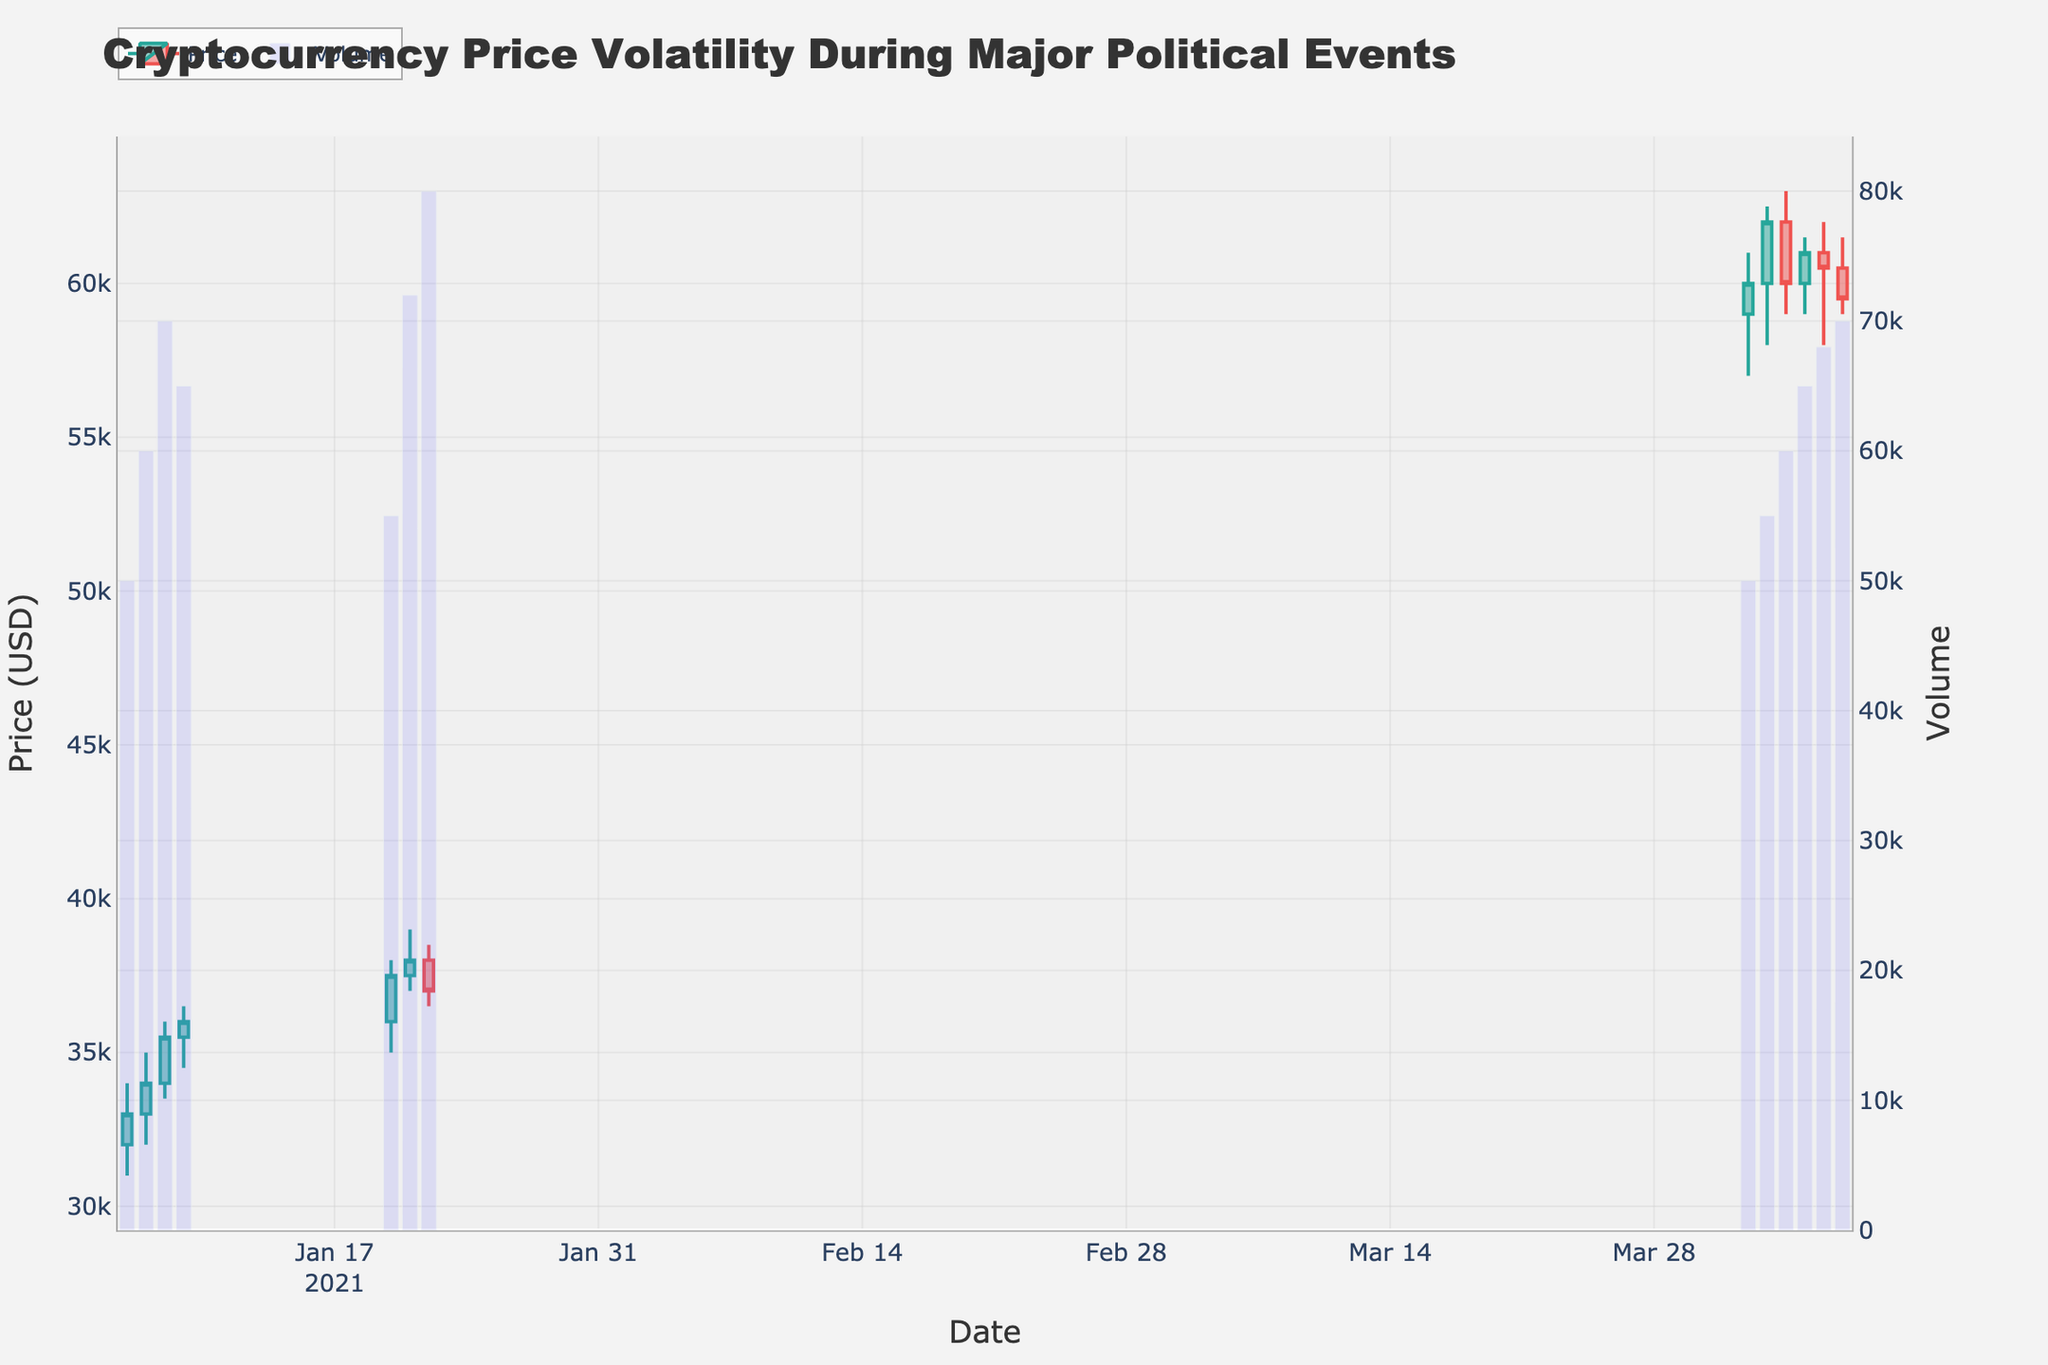What is the title of the plot? The title of the plot is found at the top of the figure. Here, it reads "Cryptocurrency Price Volatility During Major Political Events".
Answer: Cryptocurrency Price Volatility During Major Political Events What is the value of the highest closing price in April? To find the highest closing price in April, look at the "Close" values for the dates in April. The highest closing price in April is found on April 3rd at 62000.
Answer: 62000 Which date had the highest trading volume in the dataset? The highest trading volume can be identified by finding the tallest bar on the secondary y-axis, which represents volume. The date with the highest volume is January 22nd with a volume of 80000.
Answer: January 22 How did the closing price change from January 6 to January 8? To check the change, look at the closing price on January 6 (33000) and January 8 (35500). The closing price increased by 2500.
Answer: It increased by 2500 On which date did the price experience the largest single-day drop (from Open to Close)? To find the largest single-day drop, check the difference between the Open and Close prices for each date. The largest drop occurred on January 22, where the price opened at 38000 and closed at 37000, dropping by 1000.
Answer: January 22 What is the total volume traded in April? Add up the volume traded on each day in April (50000 + 55000 + 60000 + 65000 + 68000 + 70000). The total volume is 368000.
Answer: 368000 Which date saw the highest high price in January? Look at the High prices in January. The highest High is on January 21 with a value of 39000.
Answer: January 21 Compare the closing prices on January 22 and April 3. Which is higher? Check the closing prices on January 22 and April 3. The closing price on January 22 is 37000, while on April 3, it is 62000. The price on April 3 is higher.
Answer: April 3 How many days in the dataset have a closing price higher than 60000? Identify the days where the closing price is higher than 60000. The dates are April 2 (60000), April 3 (62000), and April 5 (61000). There are 3 such days.
Answer: 3 